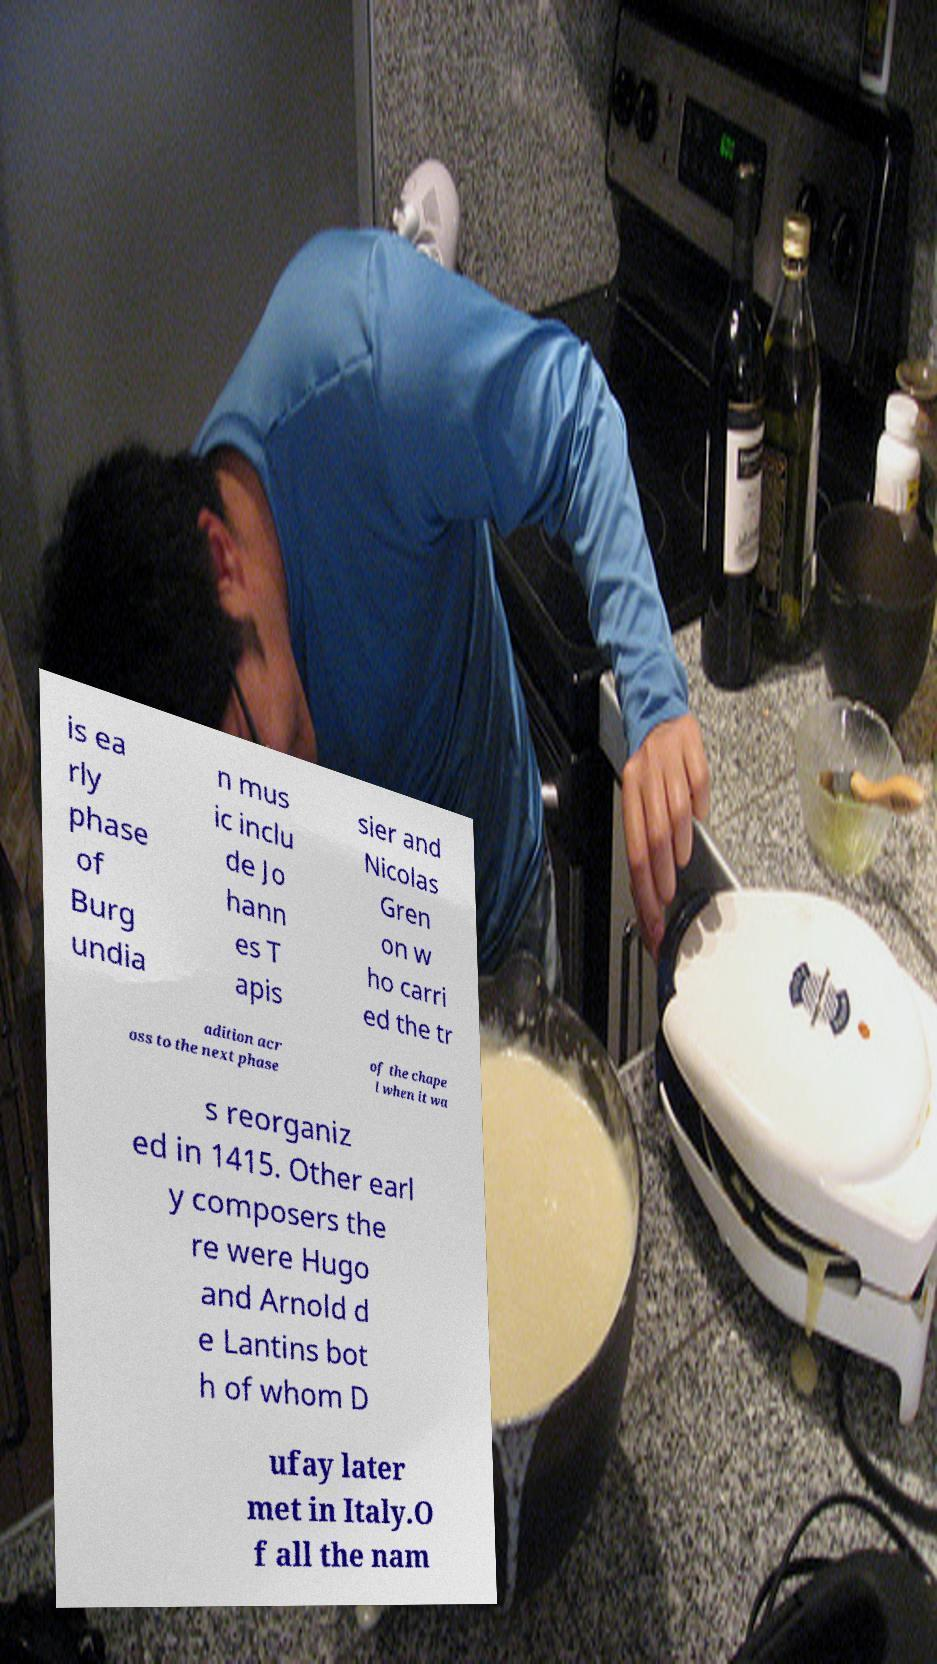Please read and relay the text visible in this image. What does it say? is ea rly phase of Burg undia n mus ic inclu de Jo hann es T apis sier and Nicolas Gren on w ho carri ed the tr adition acr oss to the next phase of the chape l when it wa s reorganiz ed in 1415. Other earl y composers the re were Hugo and Arnold d e Lantins bot h of whom D ufay later met in Italy.O f all the nam 